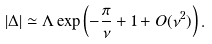Convert formula to latex. <formula><loc_0><loc_0><loc_500><loc_500>| \Delta | \simeq \Lambda \exp \left ( - \frac { \pi } { \nu } + 1 + O ( \nu ^ { 2 } ) \right ) .</formula> 